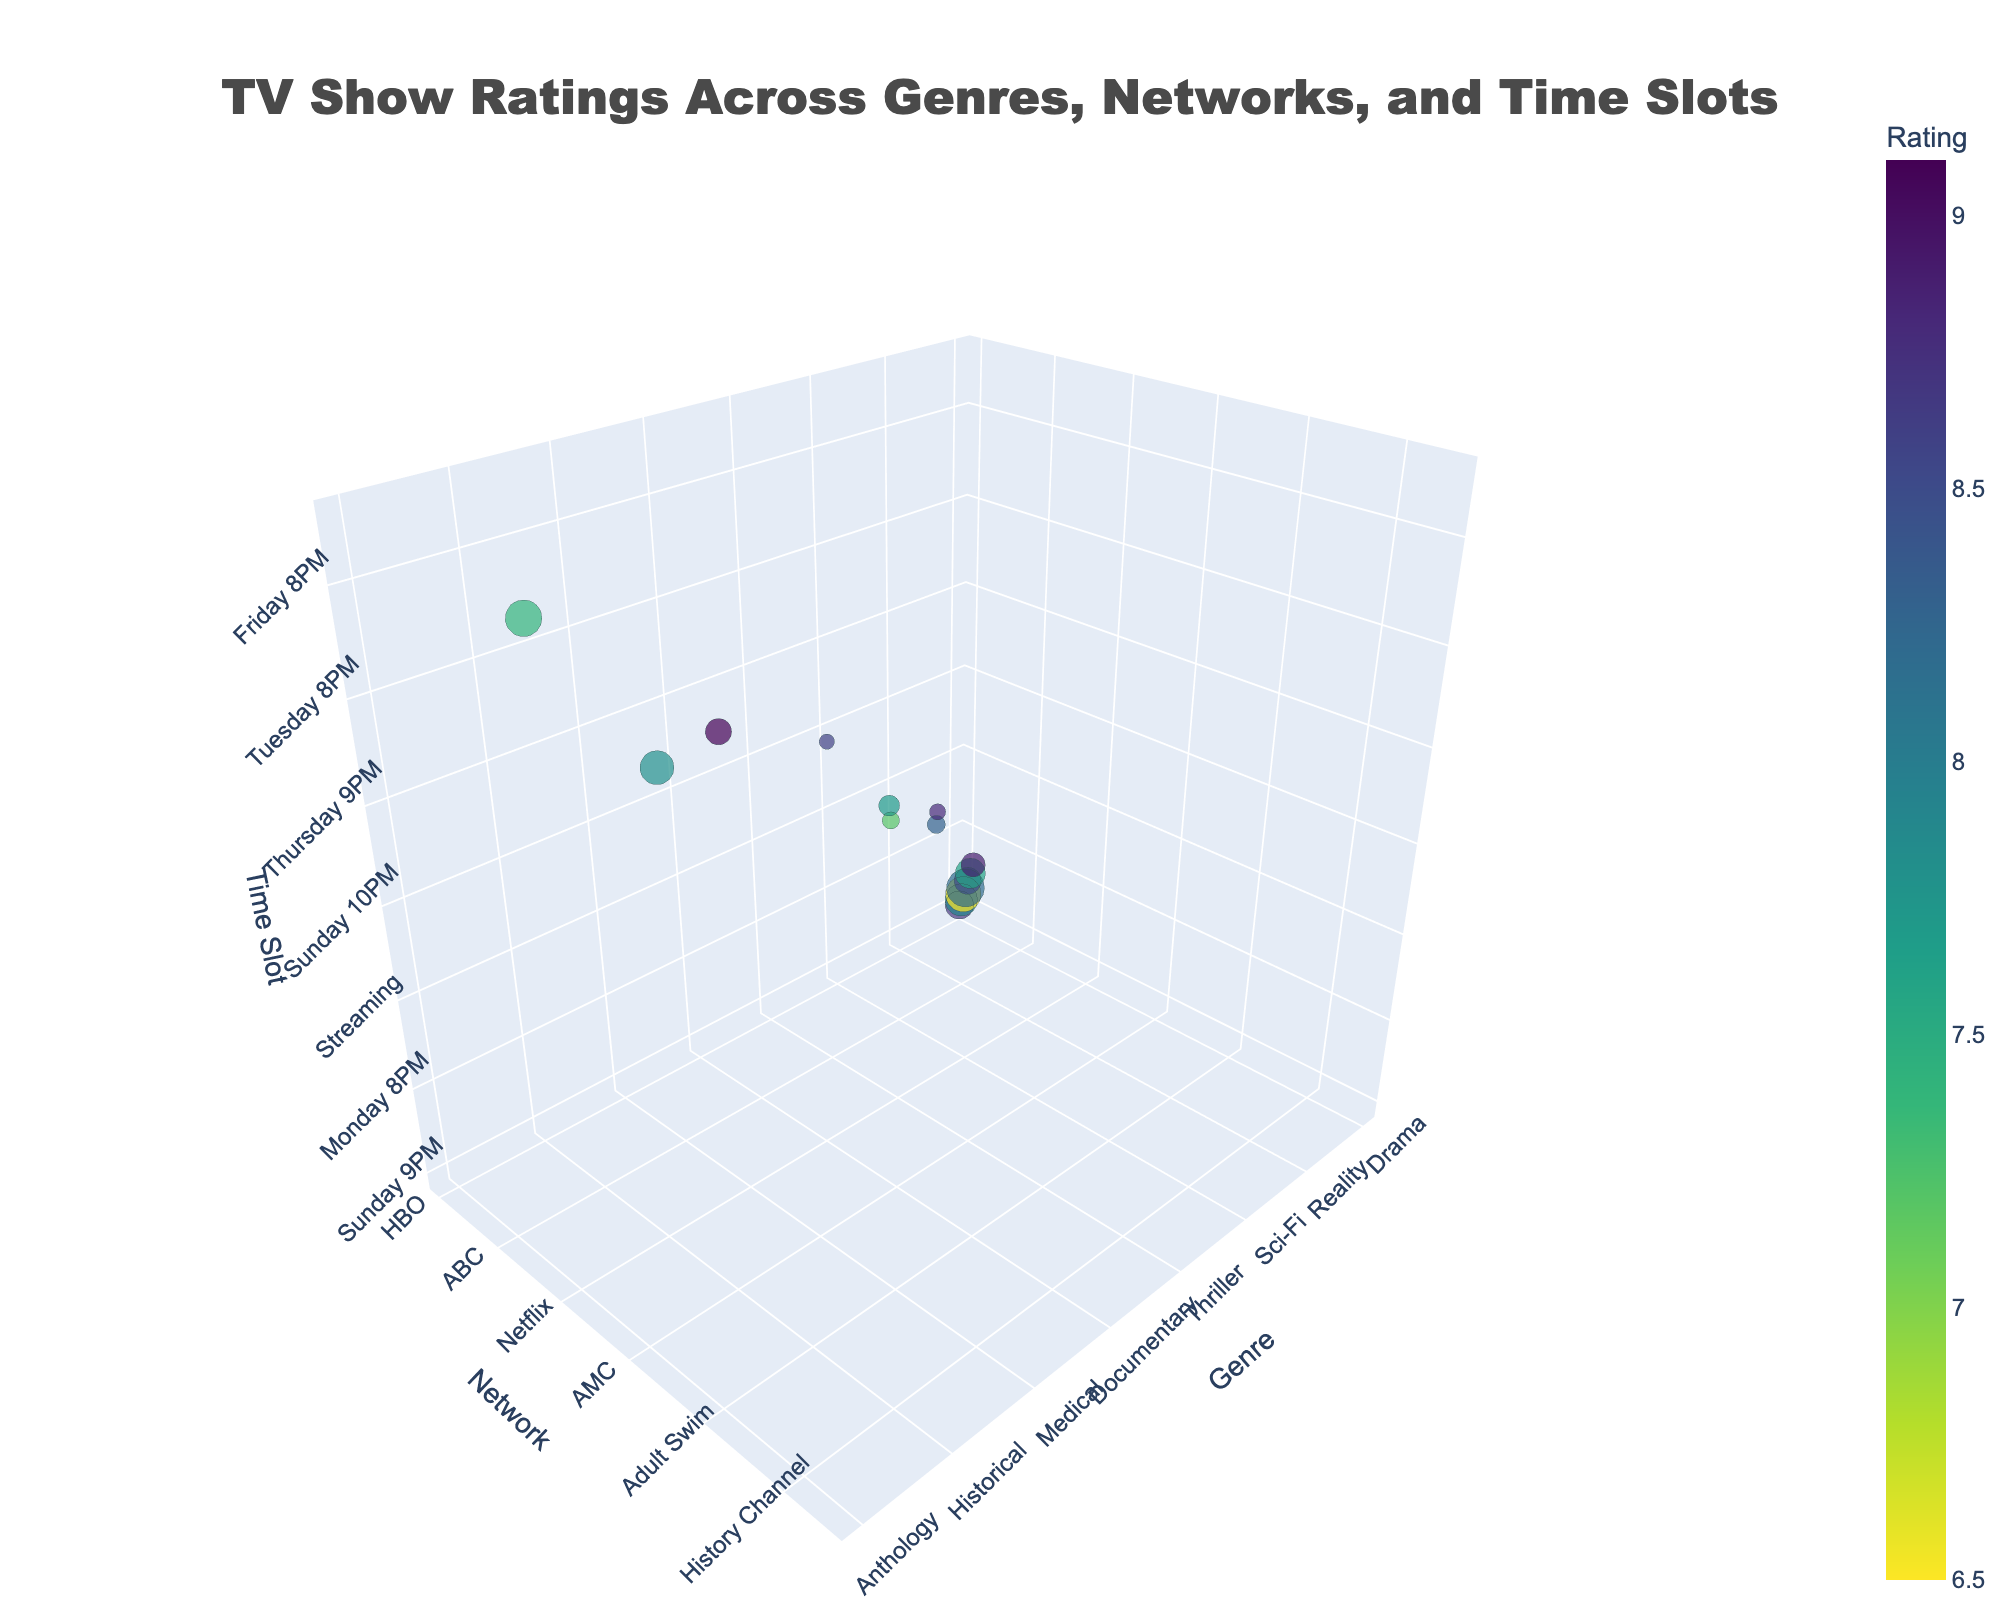What is the highest-rated genre in the figure? By examining the bubble chart and looking for the largest rating value on the color bar, you will notice that the genre "Fantasy" has the highest rating of 9.1.
Answer: Fantasy Which network has the highest and lowest viewership in millions? By observing the size of the bubbles, which represent viewership, we can find that CBS (Crime genre, Tuesday 10 PM) has the highest viewership at 9.3 million, and FX (Anthology genre, Wednesday 10 PM) has the lowest viewership at 1.5 million.
Answer: CBS highest, FX lowest How do the ratings of HBO shows on Sunday compare with each other? Locate the bubbles for HBO on Sunday (Fantasy at 8 PM and Drama at 9 PM). The ratings are 9.1 for Fantasy and 8.7 for Drama.
Answer: Fantasy (9.1) > Drama (8.7) What is the average viewership for ABC shows? ABC has shows in the Reality genre (Monday 8 PM with 8.1M) and Medical genre (Thursday 9 PM with 7.5M). The total viewership is 8.1 + 7.5 = 15.6 million, and the average is 15.6 / 2 = 7.8 million.
Answer: 7.8 million Which genre has the smallest bubble and what does it represent? The smallest bubble indicates the lowest viewership. By examining the bubble sizes, the Animated genre on Adult Swim (Sunday 11 PM) has the smallest bubble, representing a viewership of 1.7 million.
Answer: Animated Is there a network with shows in multiple genres at the same time slot? By checking the y-axis (network) and time slots, we can see that ABC has Medical and Reality genres in different time slots (Thursday 9 PM and Monday 8 PM respectively), but not at the same time slot. So the answer is no.
Answer: No Can you find a network with high ratings but low viewership? Look for bubbles with high ratings but small sizes. AMC (Thriller genre, Sunday 10 PM) has a high rating of 8.9 but lower viewership of 3.8 million.
Answer: AMC Which genre on Netflix has the rating and viewership and what are their values? Identify the bubble for Netflix, which is Sci-Fi. The rating is 8.5, and the viewership is 4.7 million.
Answer: Sci-Fi, Rating: 8.5, Viewership: 4.7 million How do the ratings for NBC and FOX shows compare? Compare the ratings where NBC has a Comedy genre (Thursday 8 PM) with a rating of 7.9 and FOX has a Sitcom genre (Wednesday 9 PM) with a rating of 7.6.
Answer: NBC (7.9) > FOX (7.6) What is the rating range seen in the chart? The ratings range from the lowest rating bubble at 6.5 (Reality, ABC, Monday 8 PM) to the highest rating bubble at 9.1 (Fantasy, HBO, Sunday 8 PM).
Answer: 6.5 to 9.1 